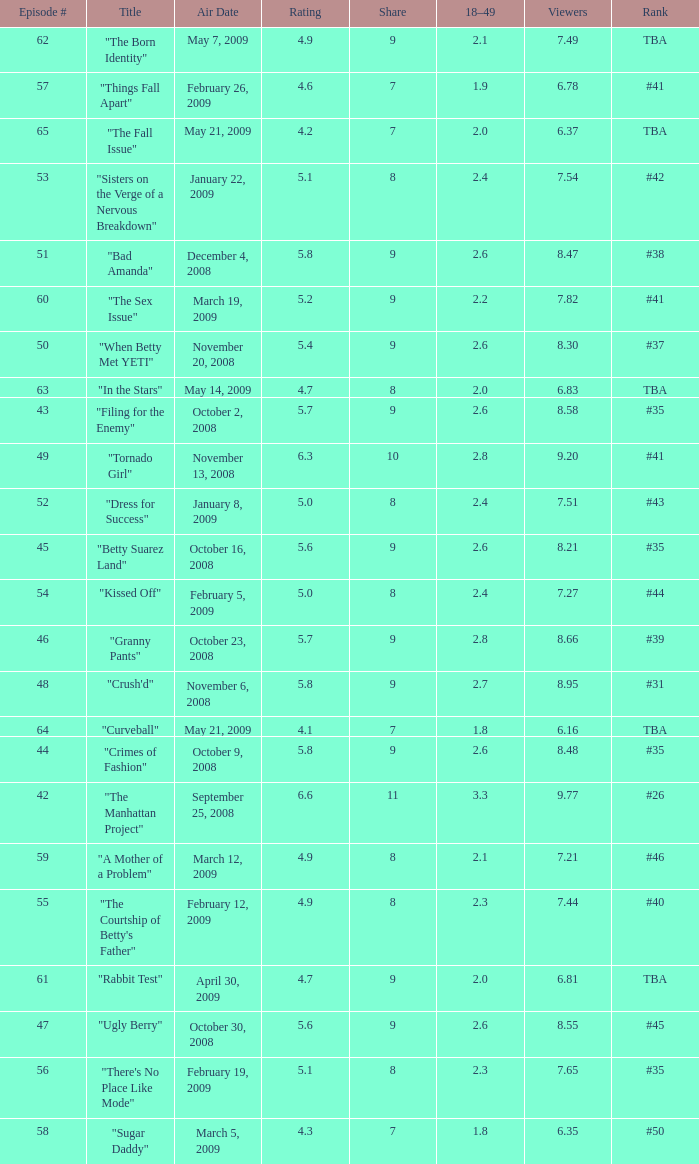What is the average Episode # with a 7 share and 18–49 is less than 2 and the Air Date of may 21, 2009? 64.0. 